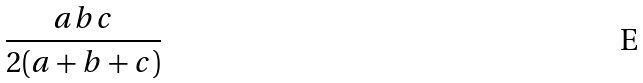<formula> <loc_0><loc_0><loc_500><loc_500>\frac { a b c } { 2 ( a + b + c ) }</formula> 